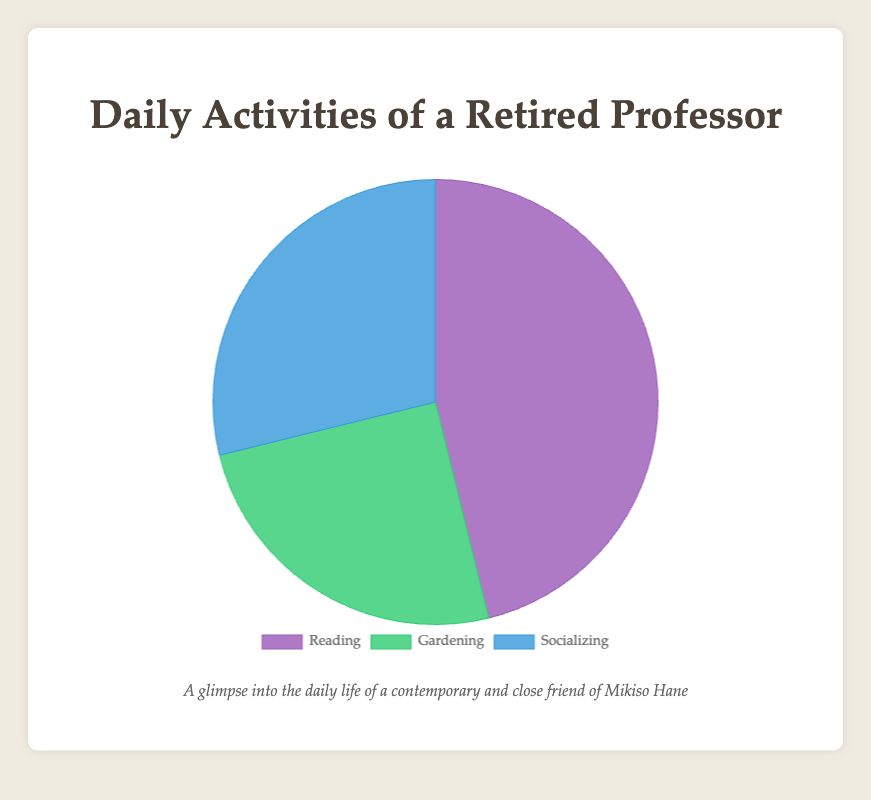What is the total time spent on Reading? To find the total time spent on Reading, sum up all the hours spent on Reading from the data: 4 + 5 + 3 = 12 hours.
Answer: 12 hours Which activity has the least amount of time spent? To determine which activity has the least amount of time spent, compare the total hours for each activity: Reading (12 hours), Gardening (6.5 hours), Socializing (7.5 hours). The activity with the least hours is Gardening with 6.5 hours.
Answer: Gardening How much more time is spent on Reading than Gardening? To find how much more time is spent on Reading than Gardening, subtract the total hours spent on Gardening from that of Reading: 12 hours (Reading) - 6.5 hours (Gardening) = 5.5 hours.
Answer: 5.5 hours What is the percentage of time spent on Socializing? First, sum up the total hours spent on all activities: 12 (Reading) + 6.5 (Gardening) + 7.5 (Socializing) = 26 hours. Then, calculate the percentage of time spent on Socializing: (7.5 / 26) * 100 ≈ 28.85%.
Answer: 28.85% What is the average time spent on Gardening per activity? To find the average time spent on Gardening, sum up the total hours spent on Gardening and divide by the number of gardening activities: (2 + 1.5 + 3) / 3 = 6.5 / 3 ≈ 2.17 hours.
Answer: 2.17 hours Which two activities combined have the majority of time spent? To find the two activities with the majority of time spent, sum up the hours for each pair and see which sum is more than 50% of the total time (26 hours): Reading + Socializing = 12 + 7.5 = 19.5 hours; Reading + Gardening = 12 + 6.5 = 18.5 hours; Gardening + Socializing = 6.5 + 7.5 = 14 hours. Reading and Socializing combined, with 19.5 hours, form the majority.
Answer: Reading and Socializing What proportion of the time is spent either Gardening or Socializing? Sum the total hours spent on Gardening and Socializing: 6.5 (Gardening) + 7.5 (Socializing) = 14 hours. Calculate the proportion: 14 / 26 ≈ 53.85%.
Answer: 53.85% Which activity is represented by the green segment in the pie chart? From the color mapping provided in the code, the green segment represents Gardening.
Answer: Gardening 